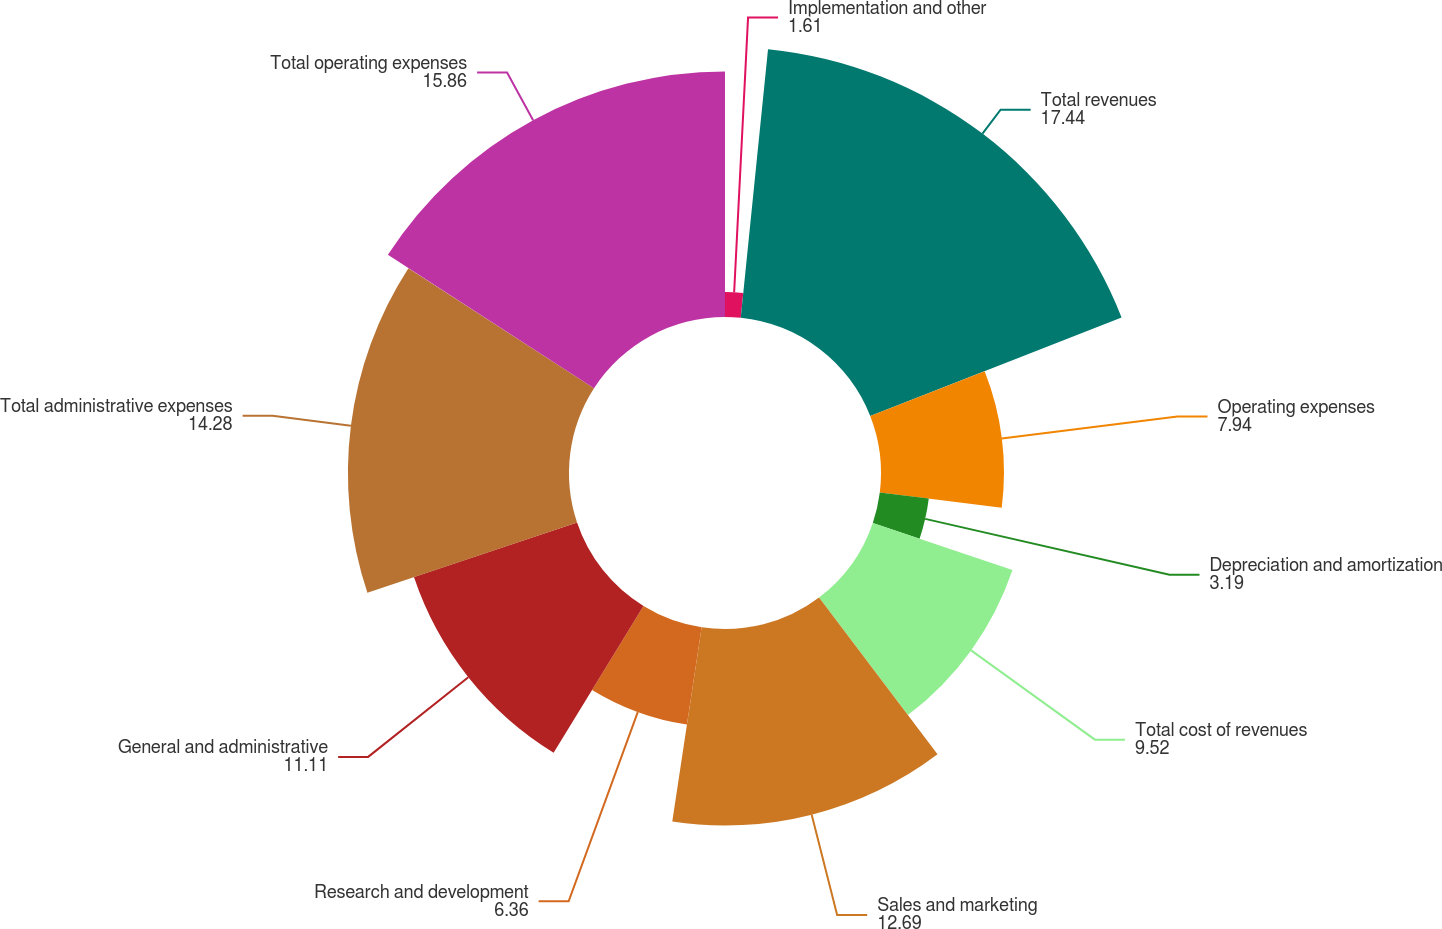Convert chart to OTSL. <chart><loc_0><loc_0><loc_500><loc_500><pie_chart><fcel>Implementation and other<fcel>Total revenues<fcel>Operating expenses<fcel>Depreciation and amortization<fcel>Total cost of revenues<fcel>Sales and marketing<fcel>Research and development<fcel>General and administrative<fcel>Total administrative expenses<fcel>Total operating expenses<nl><fcel>1.61%<fcel>17.44%<fcel>7.94%<fcel>3.19%<fcel>9.52%<fcel>12.69%<fcel>6.36%<fcel>11.11%<fcel>14.28%<fcel>15.86%<nl></chart> 